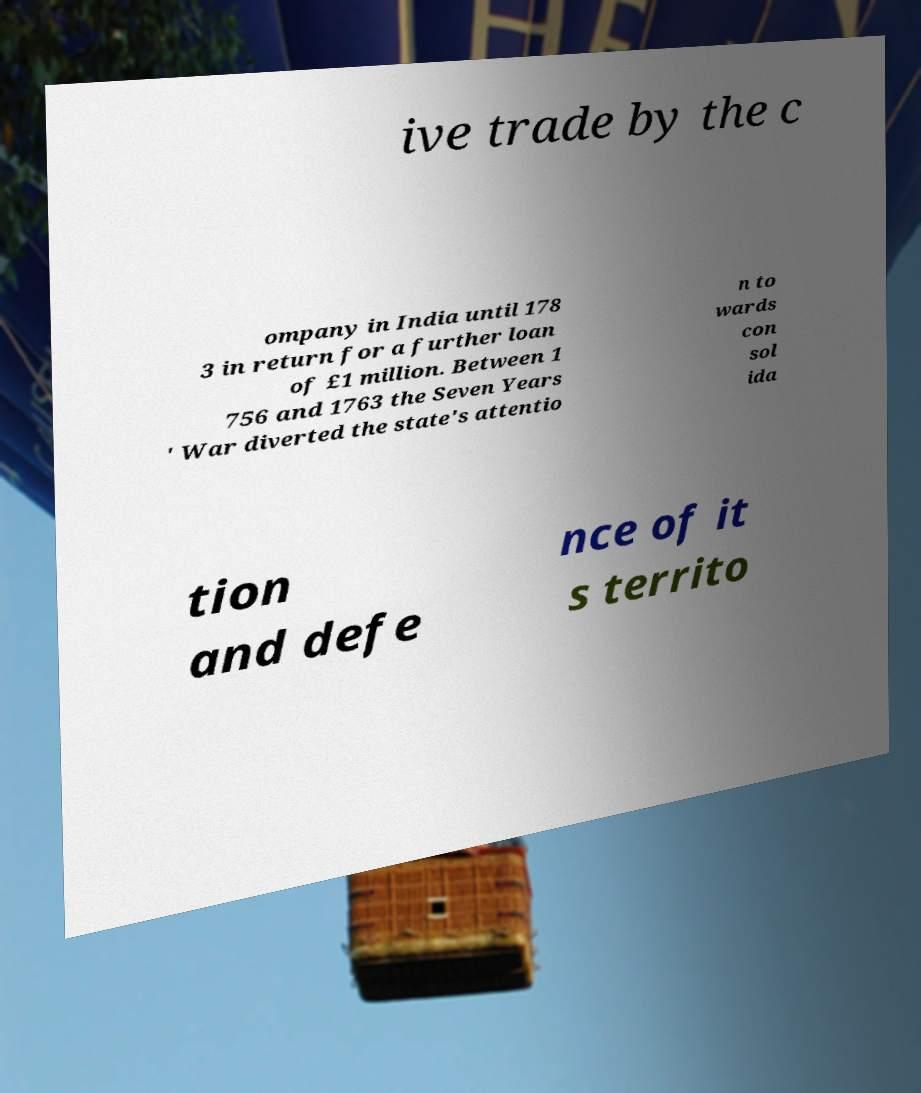I need the written content from this picture converted into text. Can you do that? ive trade by the c ompany in India until 178 3 in return for a further loan of £1 million. Between 1 756 and 1763 the Seven Years ' War diverted the state's attentio n to wards con sol ida tion and defe nce of it s territo 